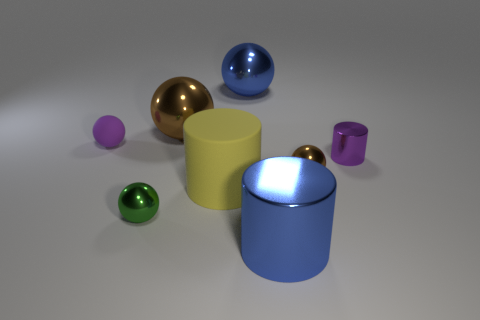Add 2 large matte objects. How many objects exist? 10 Subtract all cyan blocks. How many brown balls are left? 2 Subtract all blue cylinders. How many cylinders are left? 2 Subtract 2 balls. How many balls are left? 3 Subtract all purple spheres. How many spheres are left? 4 Subtract all balls. How many objects are left? 3 Add 7 big brown matte cylinders. How many big brown matte cylinders exist? 7 Subtract 1 green spheres. How many objects are left? 7 Subtract all blue cylinders. Subtract all cyan spheres. How many cylinders are left? 2 Subtract all brown metallic balls. Subtract all blue shiny cylinders. How many objects are left? 5 